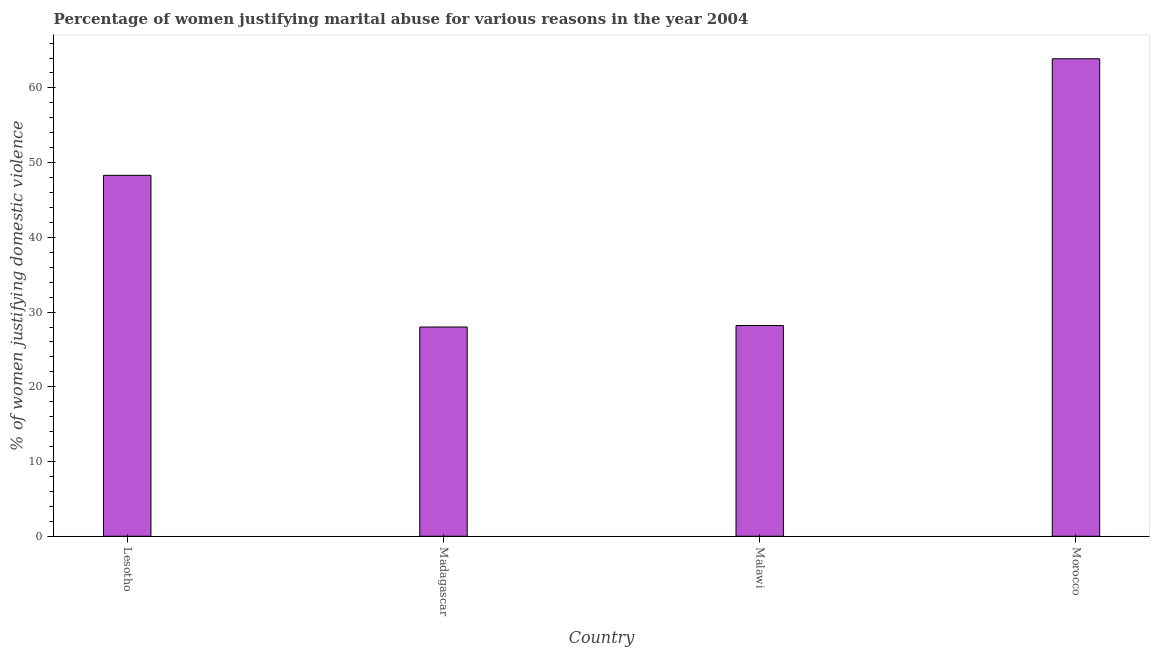Does the graph contain any zero values?
Offer a terse response. No. Does the graph contain grids?
Keep it short and to the point. No. What is the title of the graph?
Your response must be concise. Percentage of women justifying marital abuse for various reasons in the year 2004. What is the label or title of the Y-axis?
Your answer should be compact. % of women justifying domestic violence. What is the percentage of women justifying marital abuse in Lesotho?
Provide a short and direct response. 48.3. Across all countries, what is the maximum percentage of women justifying marital abuse?
Your answer should be compact. 63.9. In which country was the percentage of women justifying marital abuse maximum?
Your response must be concise. Morocco. In which country was the percentage of women justifying marital abuse minimum?
Your answer should be compact. Madagascar. What is the sum of the percentage of women justifying marital abuse?
Your answer should be very brief. 168.4. What is the difference between the percentage of women justifying marital abuse in Lesotho and Morocco?
Your response must be concise. -15.6. What is the average percentage of women justifying marital abuse per country?
Offer a terse response. 42.1. What is the median percentage of women justifying marital abuse?
Offer a very short reply. 38.25. In how many countries, is the percentage of women justifying marital abuse greater than 58 %?
Your answer should be very brief. 1. What is the ratio of the percentage of women justifying marital abuse in Madagascar to that in Morocco?
Provide a short and direct response. 0.44. Is the percentage of women justifying marital abuse in Lesotho less than that in Malawi?
Offer a terse response. No. Is the difference between the percentage of women justifying marital abuse in Malawi and Morocco greater than the difference between any two countries?
Keep it short and to the point. No. What is the difference between the highest and the second highest percentage of women justifying marital abuse?
Make the answer very short. 15.6. What is the difference between the highest and the lowest percentage of women justifying marital abuse?
Keep it short and to the point. 35.9. How many bars are there?
Offer a very short reply. 4. Are all the bars in the graph horizontal?
Give a very brief answer. No. How many countries are there in the graph?
Provide a short and direct response. 4. Are the values on the major ticks of Y-axis written in scientific E-notation?
Provide a short and direct response. No. What is the % of women justifying domestic violence in Lesotho?
Keep it short and to the point. 48.3. What is the % of women justifying domestic violence in Malawi?
Your response must be concise. 28.2. What is the % of women justifying domestic violence in Morocco?
Your response must be concise. 63.9. What is the difference between the % of women justifying domestic violence in Lesotho and Madagascar?
Ensure brevity in your answer.  20.3. What is the difference between the % of women justifying domestic violence in Lesotho and Malawi?
Offer a terse response. 20.1. What is the difference between the % of women justifying domestic violence in Lesotho and Morocco?
Provide a short and direct response. -15.6. What is the difference between the % of women justifying domestic violence in Madagascar and Morocco?
Your answer should be compact. -35.9. What is the difference between the % of women justifying domestic violence in Malawi and Morocco?
Give a very brief answer. -35.7. What is the ratio of the % of women justifying domestic violence in Lesotho to that in Madagascar?
Provide a short and direct response. 1.73. What is the ratio of the % of women justifying domestic violence in Lesotho to that in Malawi?
Provide a short and direct response. 1.71. What is the ratio of the % of women justifying domestic violence in Lesotho to that in Morocco?
Your answer should be compact. 0.76. What is the ratio of the % of women justifying domestic violence in Madagascar to that in Malawi?
Your response must be concise. 0.99. What is the ratio of the % of women justifying domestic violence in Madagascar to that in Morocco?
Your answer should be very brief. 0.44. What is the ratio of the % of women justifying domestic violence in Malawi to that in Morocco?
Your answer should be very brief. 0.44. 